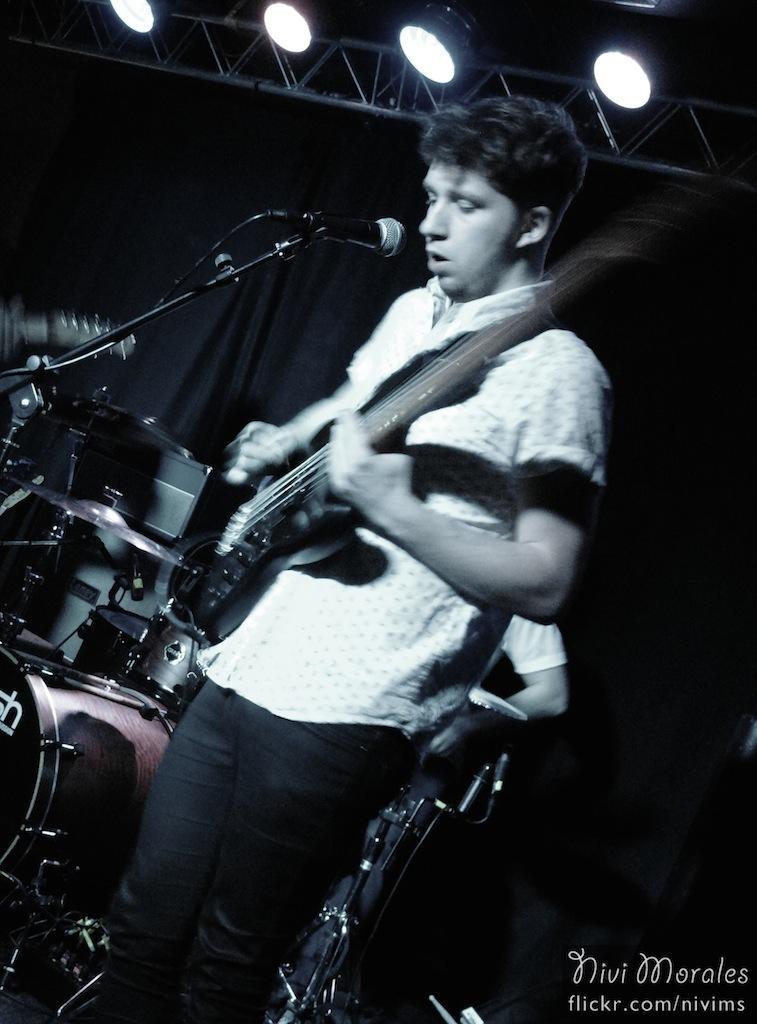Could you give a brief overview of what you see in this image? This Image is clicked in musical concert. There is a person who is playing guitar and he is singing something. There are lights on the top. There is a mic in front of him. Behind him there are drums and he is playing the drums, some other person is playing the drums. 